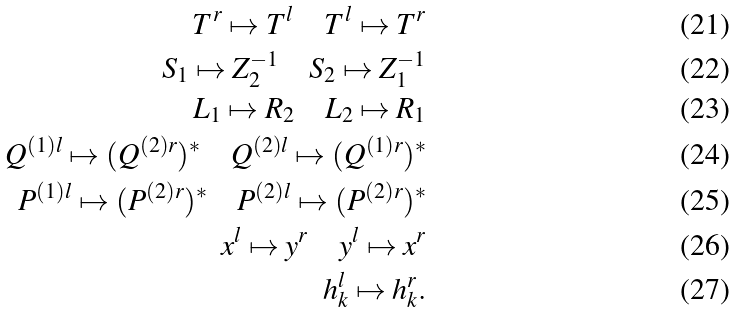<formula> <loc_0><loc_0><loc_500><loc_500>T ^ { r } \mapsto T ^ { l } \quad T ^ { l } \mapsto T ^ { r } \\ S _ { 1 } \mapsto Z _ { 2 } ^ { - 1 } \quad S _ { 2 } \mapsto Z _ { 1 } ^ { - 1 } \\ L _ { 1 } \mapsto R _ { 2 } \quad L _ { 2 } \mapsto R _ { 1 } \\ Q ^ { ( 1 ) l } \mapsto ( Q ^ { ( 2 ) r } ) ^ { * } \quad Q ^ { ( 2 ) l } \mapsto ( Q ^ { ( 1 ) r } ) ^ { * } \\ P ^ { ( 1 ) l } \mapsto ( P ^ { ( 2 ) r } ) ^ { * } \quad P ^ { ( 2 ) l } \mapsto ( P ^ { ( 2 ) r } ) ^ { * } \\ x ^ { l } \mapsto y ^ { r } \quad y ^ { l } \mapsto x ^ { r } \\ h ^ { l } _ { k } \mapsto h ^ { r } _ { k } .</formula> 